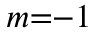Convert formula to latex. <formula><loc_0><loc_0><loc_500><loc_500>m { = } { - } 1</formula> 